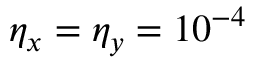<formula> <loc_0><loc_0><loc_500><loc_500>\eta _ { x } = \eta _ { y } = 1 0 ^ { - 4 }</formula> 